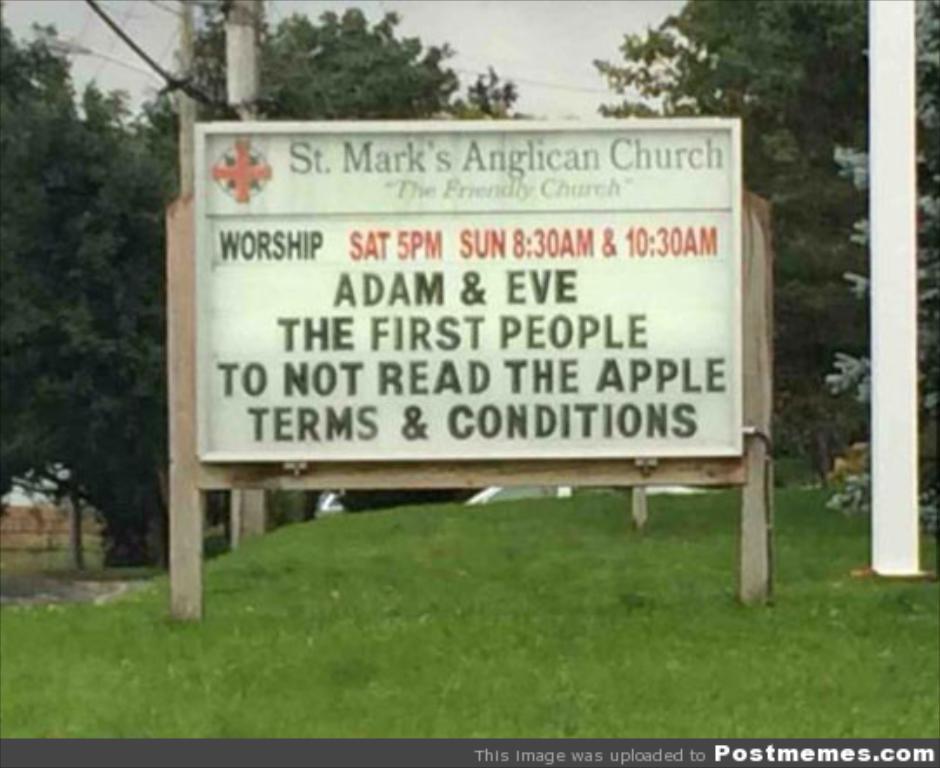Can you describe this image briefly? In this picture we can see board on wooden poles, grass, poles and trees. In the background of the image we can see the sky. In the bottom right side of the image we can see text. 